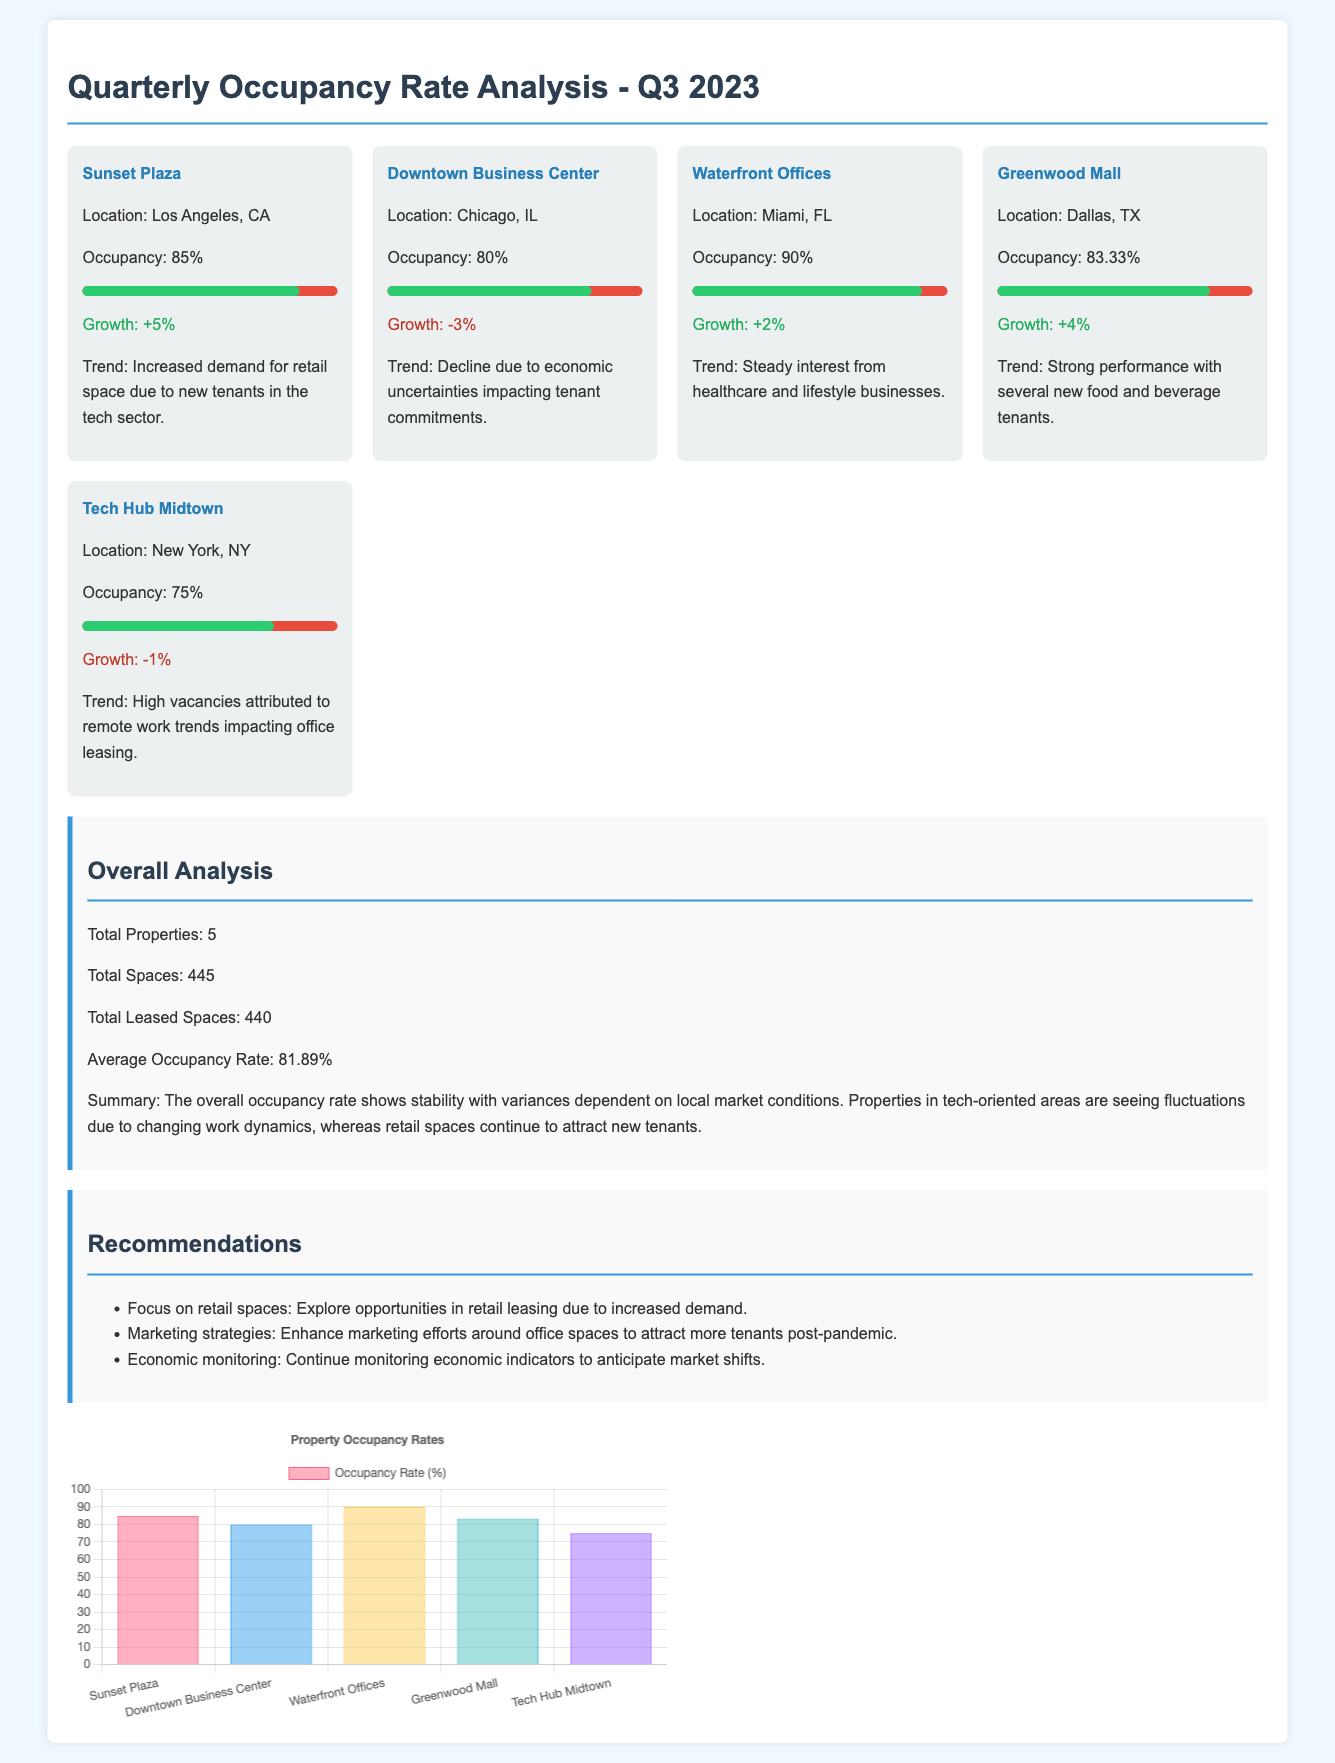What is the average occupancy rate? The average occupancy rate is calculated by taking the total leased spaces divided by total spaces across all properties, which equals approximately 81.89%.
Answer: 81.89% How many properties are analyzed? The document states the total number of properties at the beginning of the overall analysis section.
Answer: 5 Which property has the highest occupancy rate? The highest occupancy rate is mentioned in the property section, indicating the particular property with the highest percentage.
Answer: Waterfront Offices What was the growth rate for Downtown Business Center? The growth rate for Downtown Business Center is specified directly under its respective section within the property grid.
Answer: -3% What is the trend for Tech Hub Midtown? The trend for Tech Hub Midtown is described in the property card, reflecting changes in demand and its impact on occupancy.
Answer: High vacancies attributed to remote work trends impacting office leasing What is the total number of leased spaces? The total number of leased spaces is explicitly stated in the overall analysis section as part of occupancy computations.
Answer: 440 What is the occupancy percentage for Sunset Plaza? The occupancy percentage for Sunset Plaza is provided within the property card details specifically for that property.
Answer: 85% What is suggested to enhance marketing strategies? The recommendations section includes specific approaches to improve marketing strategies in response to current trends and vacancies.
Answer: Enhance marketing efforts around office spaces 